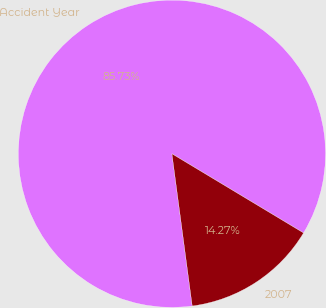<chart> <loc_0><loc_0><loc_500><loc_500><pie_chart><fcel>Accident Year<fcel>2007<nl><fcel>85.73%<fcel>14.27%<nl></chart> 